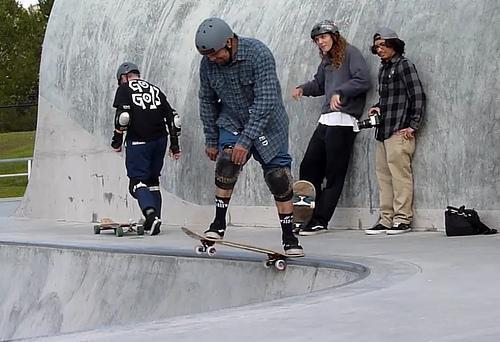How many people are in this picture?
Give a very brief answer. 4. How many people are wearing shorts?
Give a very brief answer. 1. How many people are walking away?
Give a very brief answer. 1. 